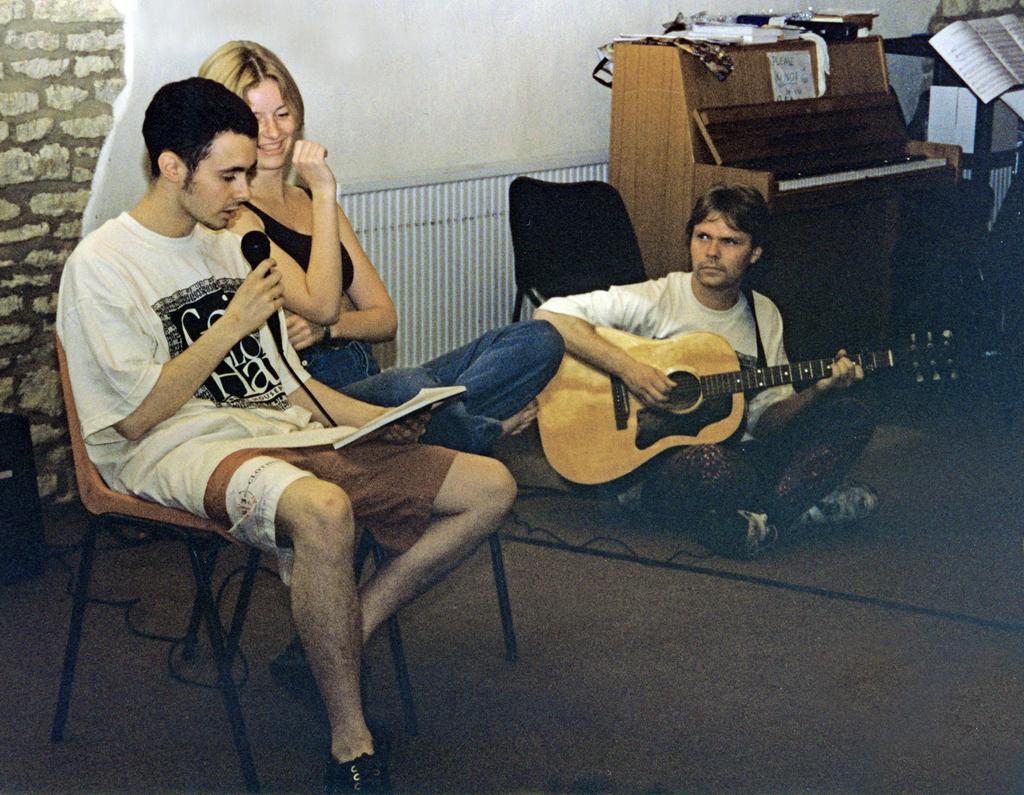How would you summarize this image in a sentence or two? On the background we can see a wall with bricks. Here we can see a woman and a man sitting on chairs. This man is holding a mike and a paper in his hand and singing. We can see other man sitting on the floor and playing guitar. Here we can see a piano table. Here we can see a book. This is a wall in white color. This is a floor. 